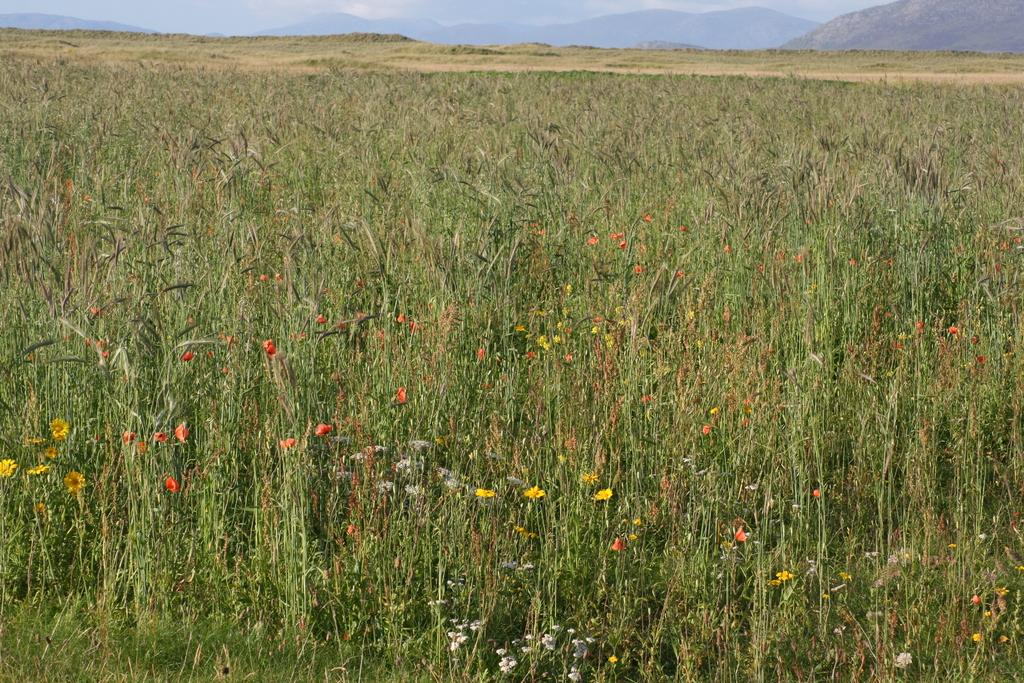What type of natural formation can be seen in the image? There are mountains in the image. What is the status of the plants in the image? Some of the plants in the image are planted, and some have flowers. What type of vegetation covers the ground in the image? There is grass on the ground in the image. What is the condition of the sky in the image? The sky is visible at the top of the image and appears to be cloudy. What day of the week is depicted in the image? The image does not depict a specific day of the week; it is a still image of a landscape. How many quarters are visible in the image? There are no quarters present in the image; it features mountains, plants, grass, and a cloudy sky. 